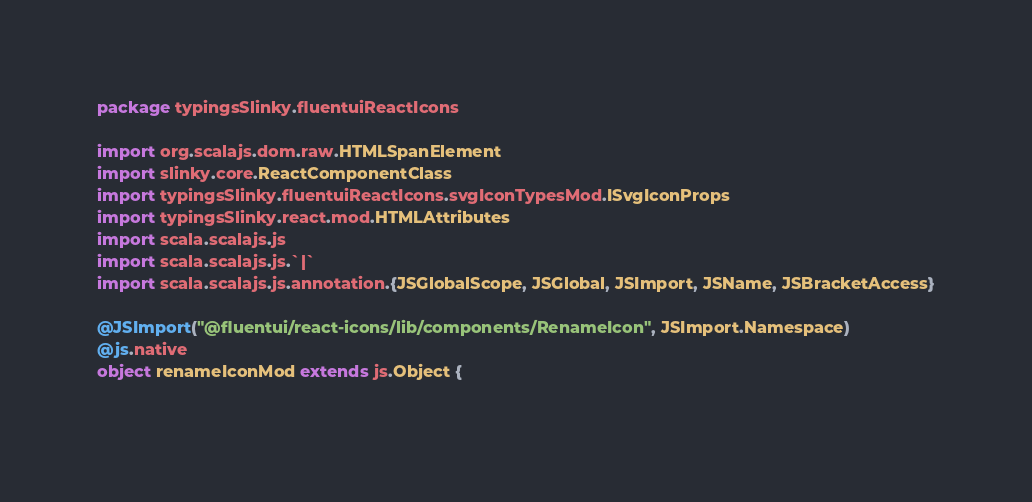<code> <loc_0><loc_0><loc_500><loc_500><_Scala_>package typingsSlinky.fluentuiReactIcons

import org.scalajs.dom.raw.HTMLSpanElement
import slinky.core.ReactComponentClass
import typingsSlinky.fluentuiReactIcons.svgIconTypesMod.ISvgIconProps
import typingsSlinky.react.mod.HTMLAttributes
import scala.scalajs.js
import scala.scalajs.js.`|`
import scala.scalajs.js.annotation.{JSGlobalScope, JSGlobal, JSImport, JSName, JSBracketAccess}

@JSImport("@fluentui/react-icons/lib/components/RenameIcon", JSImport.Namespace)
@js.native
object renameIconMod extends js.Object {
  </code> 